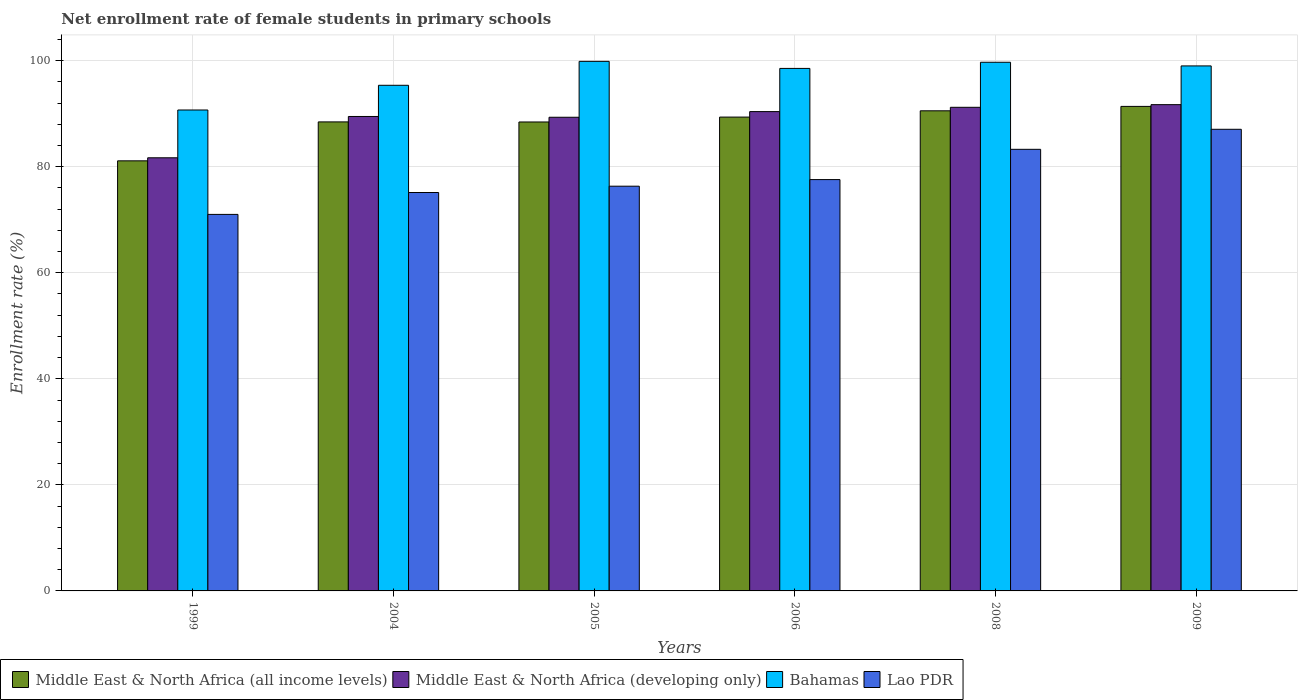Are the number of bars per tick equal to the number of legend labels?
Your answer should be compact. Yes. Are the number of bars on each tick of the X-axis equal?
Give a very brief answer. Yes. How many bars are there on the 1st tick from the left?
Provide a short and direct response. 4. What is the label of the 1st group of bars from the left?
Your response must be concise. 1999. In how many cases, is the number of bars for a given year not equal to the number of legend labels?
Keep it short and to the point. 0. What is the net enrollment rate of female students in primary schools in Bahamas in 2005?
Ensure brevity in your answer.  99.86. Across all years, what is the maximum net enrollment rate of female students in primary schools in Lao PDR?
Offer a very short reply. 87.05. Across all years, what is the minimum net enrollment rate of female students in primary schools in Bahamas?
Give a very brief answer. 90.69. In which year was the net enrollment rate of female students in primary schools in Middle East & North Africa (developing only) maximum?
Your answer should be compact. 2009. What is the total net enrollment rate of female students in primary schools in Middle East & North Africa (developing only) in the graph?
Offer a very short reply. 533.75. What is the difference between the net enrollment rate of female students in primary schools in Middle East & North Africa (all income levels) in 1999 and that in 2004?
Your answer should be very brief. -7.34. What is the difference between the net enrollment rate of female students in primary schools in Middle East & North Africa (all income levels) in 2006 and the net enrollment rate of female students in primary schools in Lao PDR in 2004?
Keep it short and to the point. 14.22. What is the average net enrollment rate of female students in primary schools in Bahamas per year?
Provide a short and direct response. 97.19. In the year 2008, what is the difference between the net enrollment rate of female students in primary schools in Lao PDR and net enrollment rate of female students in primary schools in Middle East & North Africa (all income levels)?
Your answer should be very brief. -7.26. In how many years, is the net enrollment rate of female students in primary schools in Middle East & North Africa (all income levels) greater than 84 %?
Ensure brevity in your answer.  5. What is the ratio of the net enrollment rate of female students in primary schools in Middle East & North Africa (all income levels) in 1999 to that in 2005?
Offer a terse response. 0.92. What is the difference between the highest and the second highest net enrollment rate of female students in primary schools in Middle East & North Africa (all income levels)?
Your answer should be very brief. 0.83. What is the difference between the highest and the lowest net enrollment rate of female students in primary schools in Middle East & North Africa (developing only)?
Give a very brief answer. 10.02. In how many years, is the net enrollment rate of female students in primary schools in Bahamas greater than the average net enrollment rate of female students in primary schools in Bahamas taken over all years?
Ensure brevity in your answer.  4. Is the sum of the net enrollment rate of female students in primary schools in Middle East & North Africa (developing only) in 2004 and 2008 greater than the maximum net enrollment rate of female students in primary schools in Lao PDR across all years?
Make the answer very short. Yes. What does the 2nd bar from the left in 2008 represents?
Offer a very short reply. Middle East & North Africa (developing only). What does the 4th bar from the right in 2004 represents?
Offer a terse response. Middle East & North Africa (all income levels). Is it the case that in every year, the sum of the net enrollment rate of female students in primary schools in Lao PDR and net enrollment rate of female students in primary schools in Middle East & North Africa (developing only) is greater than the net enrollment rate of female students in primary schools in Bahamas?
Make the answer very short. Yes. How many bars are there?
Make the answer very short. 24. Are all the bars in the graph horizontal?
Your answer should be compact. No. Are the values on the major ticks of Y-axis written in scientific E-notation?
Your answer should be compact. No. Does the graph contain any zero values?
Ensure brevity in your answer.  No. How many legend labels are there?
Keep it short and to the point. 4. How are the legend labels stacked?
Your response must be concise. Horizontal. What is the title of the graph?
Offer a terse response. Net enrollment rate of female students in primary schools. What is the label or title of the Y-axis?
Give a very brief answer. Enrollment rate (%). What is the Enrollment rate (%) of Middle East & North Africa (all income levels) in 1999?
Your answer should be very brief. 81.1. What is the Enrollment rate (%) in Middle East & North Africa (developing only) in 1999?
Make the answer very short. 81.68. What is the Enrollment rate (%) of Bahamas in 1999?
Make the answer very short. 90.69. What is the Enrollment rate (%) of Lao PDR in 1999?
Offer a very short reply. 71. What is the Enrollment rate (%) in Middle East & North Africa (all income levels) in 2004?
Provide a short and direct response. 88.44. What is the Enrollment rate (%) in Middle East & North Africa (developing only) in 2004?
Your answer should be compact. 89.47. What is the Enrollment rate (%) in Bahamas in 2004?
Offer a terse response. 95.35. What is the Enrollment rate (%) of Lao PDR in 2004?
Your answer should be very brief. 75.13. What is the Enrollment rate (%) in Middle East & North Africa (all income levels) in 2005?
Offer a terse response. 88.43. What is the Enrollment rate (%) in Middle East & North Africa (developing only) in 2005?
Make the answer very short. 89.32. What is the Enrollment rate (%) in Bahamas in 2005?
Ensure brevity in your answer.  99.86. What is the Enrollment rate (%) in Lao PDR in 2005?
Offer a terse response. 76.32. What is the Enrollment rate (%) in Middle East & North Africa (all income levels) in 2006?
Your response must be concise. 89.35. What is the Enrollment rate (%) of Middle East & North Africa (developing only) in 2006?
Offer a very short reply. 90.39. What is the Enrollment rate (%) of Bahamas in 2006?
Offer a terse response. 98.53. What is the Enrollment rate (%) in Lao PDR in 2006?
Provide a short and direct response. 77.57. What is the Enrollment rate (%) of Middle East & North Africa (all income levels) in 2008?
Keep it short and to the point. 90.54. What is the Enrollment rate (%) of Middle East & North Africa (developing only) in 2008?
Your response must be concise. 91.2. What is the Enrollment rate (%) of Bahamas in 2008?
Provide a short and direct response. 99.69. What is the Enrollment rate (%) of Lao PDR in 2008?
Your answer should be compact. 83.27. What is the Enrollment rate (%) of Middle East & North Africa (all income levels) in 2009?
Offer a very short reply. 91.37. What is the Enrollment rate (%) of Middle East & North Africa (developing only) in 2009?
Give a very brief answer. 91.7. What is the Enrollment rate (%) of Bahamas in 2009?
Keep it short and to the point. 99. What is the Enrollment rate (%) in Lao PDR in 2009?
Offer a terse response. 87.05. Across all years, what is the maximum Enrollment rate (%) in Middle East & North Africa (all income levels)?
Your response must be concise. 91.37. Across all years, what is the maximum Enrollment rate (%) of Middle East & North Africa (developing only)?
Make the answer very short. 91.7. Across all years, what is the maximum Enrollment rate (%) in Bahamas?
Ensure brevity in your answer.  99.86. Across all years, what is the maximum Enrollment rate (%) of Lao PDR?
Keep it short and to the point. 87.05. Across all years, what is the minimum Enrollment rate (%) in Middle East & North Africa (all income levels)?
Keep it short and to the point. 81.1. Across all years, what is the minimum Enrollment rate (%) in Middle East & North Africa (developing only)?
Make the answer very short. 81.68. Across all years, what is the minimum Enrollment rate (%) of Bahamas?
Keep it short and to the point. 90.69. Across all years, what is the minimum Enrollment rate (%) in Lao PDR?
Provide a short and direct response. 71. What is the total Enrollment rate (%) in Middle East & North Africa (all income levels) in the graph?
Provide a short and direct response. 529.24. What is the total Enrollment rate (%) of Middle East & North Africa (developing only) in the graph?
Your answer should be very brief. 533.75. What is the total Enrollment rate (%) in Bahamas in the graph?
Ensure brevity in your answer.  583.13. What is the total Enrollment rate (%) of Lao PDR in the graph?
Give a very brief answer. 470.35. What is the difference between the Enrollment rate (%) of Middle East & North Africa (all income levels) in 1999 and that in 2004?
Offer a terse response. -7.34. What is the difference between the Enrollment rate (%) in Middle East & North Africa (developing only) in 1999 and that in 2004?
Provide a short and direct response. -7.79. What is the difference between the Enrollment rate (%) in Bahamas in 1999 and that in 2004?
Provide a succinct answer. -4.66. What is the difference between the Enrollment rate (%) of Lao PDR in 1999 and that in 2004?
Offer a very short reply. -4.13. What is the difference between the Enrollment rate (%) of Middle East & North Africa (all income levels) in 1999 and that in 2005?
Your answer should be very brief. -7.33. What is the difference between the Enrollment rate (%) in Middle East & North Africa (developing only) in 1999 and that in 2005?
Offer a very short reply. -7.64. What is the difference between the Enrollment rate (%) of Bahamas in 1999 and that in 2005?
Make the answer very short. -9.17. What is the difference between the Enrollment rate (%) in Lao PDR in 1999 and that in 2005?
Offer a very short reply. -5.32. What is the difference between the Enrollment rate (%) in Middle East & North Africa (all income levels) in 1999 and that in 2006?
Ensure brevity in your answer.  -8.25. What is the difference between the Enrollment rate (%) of Middle East & North Africa (developing only) in 1999 and that in 2006?
Make the answer very short. -8.71. What is the difference between the Enrollment rate (%) of Bahamas in 1999 and that in 2006?
Your response must be concise. -7.84. What is the difference between the Enrollment rate (%) in Lao PDR in 1999 and that in 2006?
Ensure brevity in your answer.  -6.57. What is the difference between the Enrollment rate (%) of Middle East & North Africa (all income levels) in 1999 and that in 2008?
Keep it short and to the point. -9.43. What is the difference between the Enrollment rate (%) of Middle East & North Africa (developing only) in 1999 and that in 2008?
Provide a short and direct response. -9.52. What is the difference between the Enrollment rate (%) in Bahamas in 1999 and that in 2008?
Provide a short and direct response. -9. What is the difference between the Enrollment rate (%) of Lao PDR in 1999 and that in 2008?
Provide a short and direct response. -12.27. What is the difference between the Enrollment rate (%) in Middle East & North Africa (all income levels) in 1999 and that in 2009?
Give a very brief answer. -10.26. What is the difference between the Enrollment rate (%) of Middle East & North Africa (developing only) in 1999 and that in 2009?
Keep it short and to the point. -10.02. What is the difference between the Enrollment rate (%) of Bahamas in 1999 and that in 2009?
Offer a very short reply. -8.31. What is the difference between the Enrollment rate (%) in Lao PDR in 1999 and that in 2009?
Offer a terse response. -16.05. What is the difference between the Enrollment rate (%) of Middle East & North Africa (all income levels) in 2004 and that in 2005?
Provide a succinct answer. 0.01. What is the difference between the Enrollment rate (%) in Middle East & North Africa (developing only) in 2004 and that in 2005?
Your response must be concise. 0.15. What is the difference between the Enrollment rate (%) of Bahamas in 2004 and that in 2005?
Make the answer very short. -4.51. What is the difference between the Enrollment rate (%) of Lao PDR in 2004 and that in 2005?
Offer a very short reply. -1.19. What is the difference between the Enrollment rate (%) in Middle East & North Africa (all income levels) in 2004 and that in 2006?
Offer a very short reply. -0.91. What is the difference between the Enrollment rate (%) in Middle East & North Africa (developing only) in 2004 and that in 2006?
Offer a terse response. -0.92. What is the difference between the Enrollment rate (%) of Bahamas in 2004 and that in 2006?
Your response must be concise. -3.18. What is the difference between the Enrollment rate (%) of Lao PDR in 2004 and that in 2006?
Offer a very short reply. -2.44. What is the difference between the Enrollment rate (%) of Middle East & North Africa (all income levels) in 2004 and that in 2008?
Offer a very short reply. -2.09. What is the difference between the Enrollment rate (%) of Middle East & North Africa (developing only) in 2004 and that in 2008?
Make the answer very short. -1.73. What is the difference between the Enrollment rate (%) of Bahamas in 2004 and that in 2008?
Your answer should be very brief. -4.34. What is the difference between the Enrollment rate (%) in Lao PDR in 2004 and that in 2008?
Provide a succinct answer. -8.15. What is the difference between the Enrollment rate (%) of Middle East & North Africa (all income levels) in 2004 and that in 2009?
Offer a terse response. -2.92. What is the difference between the Enrollment rate (%) in Middle East & North Africa (developing only) in 2004 and that in 2009?
Your answer should be very brief. -2.23. What is the difference between the Enrollment rate (%) of Bahamas in 2004 and that in 2009?
Your response must be concise. -3.65. What is the difference between the Enrollment rate (%) in Lao PDR in 2004 and that in 2009?
Offer a terse response. -11.92. What is the difference between the Enrollment rate (%) of Middle East & North Africa (all income levels) in 2005 and that in 2006?
Give a very brief answer. -0.92. What is the difference between the Enrollment rate (%) in Middle East & North Africa (developing only) in 2005 and that in 2006?
Give a very brief answer. -1.07. What is the difference between the Enrollment rate (%) of Bahamas in 2005 and that in 2006?
Keep it short and to the point. 1.33. What is the difference between the Enrollment rate (%) of Lao PDR in 2005 and that in 2006?
Your answer should be very brief. -1.25. What is the difference between the Enrollment rate (%) of Middle East & North Africa (all income levels) in 2005 and that in 2008?
Your response must be concise. -2.11. What is the difference between the Enrollment rate (%) of Middle East & North Africa (developing only) in 2005 and that in 2008?
Offer a terse response. -1.88. What is the difference between the Enrollment rate (%) of Bahamas in 2005 and that in 2008?
Your answer should be very brief. 0.17. What is the difference between the Enrollment rate (%) of Lao PDR in 2005 and that in 2008?
Keep it short and to the point. -6.95. What is the difference between the Enrollment rate (%) of Middle East & North Africa (all income levels) in 2005 and that in 2009?
Ensure brevity in your answer.  -2.94. What is the difference between the Enrollment rate (%) in Middle East & North Africa (developing only) in 2005 and that in 2009?
Offer a very short reply. -2.38. What is the difference between the Enrollment rate (%) in Bahamas in 2005 and that in 2009?
Your answer should be compact. 0.86. What is the difference between the Enrollment rate (%) of Lao PDR in 2005 and that in 2009?
Your response must be concise. -10.73. What is the difference between the Enrollment rate (%) of Middle East & North Africa (all income levels) in 2006 and that in 2008?
Your answer should be compact. -1.18. What is the difference between the Enrollment rate (%) of Middle East & North Africa (developing only) in 2006 and that in 2008?
Provide a short and direct response. -0.81. What is the difference between the Enrollment rate (%) of Bahamas in 2006 and that in 2008?
Offer a very short reply. -1.16. What is the difference between the Enrollment rate (%) of Lao PDR in 2006 and that in 2008?
Offer a terse response. -5.71. What is the difference between the Enrollment rate (%) of Middle East & North Africa (all income levels) in 2006 and that in 2009?
Give a very brief answer. -2.01. What is the difference between the Enrollment rate (%) of Middle East & North Africa (developing only) in 2006 and that in 2009?
Make the answer very short. -1.31. What is the difference between the Enrollment rate (%) of Bahamas in 2006 and that in 2009?
Offer a very short reply. -0.47. What is the difference between the Enrollment rate (%) of Lao PDR in 2006 and that in 2009?
Your answer should be very brief. -9.48. What is the difference between the Enrollment rate (%) of Middle East & North Africa (all income levels) in 2008 and that in 2009?
Ensure brevity in your answer.  -0.83. What is the difference between the Enrollment rate (%) in Middle East & North Africa (developing only) in 2008 and that in 2009?
Provide a succinct answer. -0.5. What is the difference between the Enrollment rate (%) of Bahamas in 2008 and that in 2009?
Offer a very short reply. 0.69. What is the difference between the Enrollment rate (%) of Lao PDR in 2008 and that in 2009?
Offer a very short reply. -3.78. What is the difference between the Enrollment rate (%) in Middle East & North Africa (all income levels) in 1999 and the Enrollment rate (%) in Middle East & North Africa (developing only) in 2004?
Ensure brevity in your answer.  -8.37. What is the difference between the Enrollment rate (%) in Middle East & North Africa (all income levels) in 1999 and the Enrollment rate (%) in Bahamas in 2004?
Your response must be concise. -14.25. What is the difference between the Enrollment rate (%) of Middle East & North Africa (all income levels) in 1999 and the Enrollment rate (%) of Lao PDR in 2004?
Your response must be concise. 5.97. What is the difference between the Enrollment rate (%) of Middle East & North Africa (developing only) in 1999 and the Enrollment rate (%) of Bahamas in 2004?
Make the answer very short. -13.67. What is the difference between the Enrollment rate (%) in Middle East & North Africa (developing only) in 1999 and the Enrollment rate (%) in Lao PDR in 2004?
Keep it short and to the point. 6.55. What is the difference between the Enrollment rate (%) of Bahamas in 1999 and the Enrollment rate (%) of Lao PDR in 2004?
Ensure brevity in your answer.  15.56. What is the difference between the Enrollment rate (%) of Middle East & North Africa (all income levels) in 1999 and the Enrollment rate (%) of Middle East & North Africa (developing only) in 2005?
Ensure brevity in your answer.  -8.22. What is the difference between the Enrollment rate (%) in Middle East & North Africa (all income levels) in 1999 and the Enrollment rate (%) in Bahamas in 2005?
Your answer should be compact. -18.76. What is the difference between the Enrollment rate (%) in Middle East & North Africa (all income levels) in 1999 and the Enrollment rate (%) in Lao PDR in 2005?
Your answer should be compact. 4.78. What is the difference between the Enrollment rate (%) of Middle East & North Africa (developing only) in 1999 and the Enrollment rate (%) of Bahamas in 2005?
Provide a succinct answer. -18.18. What is the difference between the Enrollment rate (%) of Middle East & North Africa (developing only) in 1999 and the Enrollment rate (%) of Lao PDR in 2005?
Offer a terse response. 5.36. What is the difference between the Enrollment rate (%) in Bahamas in 1999 and the Enrollment rate (%) in Lao PDR in 2005?
Provide a short and direct response. 14.37. What is the difference between the Enrollment rate (%) of Middle East & North Africa (all income levels) in 1999 and the Enrollment rate (%) of Middle East & North Africa (developing only) in 2006?
Your answer should be compact. -9.28. What is the difference between the Enrollment rate (%) in Middle East & North Africa (all income levels) in 1999 and the Enrollment rate (%) in Bahamas in 2006?
Your response must be concise. -17.43. What is the difference between the Enrollment rate (%) in Middle East & North Africa (all income levels) in 1999 and the Enrollment rate (%) in Lao PDR in 2006?
Provide a succinct answer. 3.53. What is the difference between the Enrollment rate (%) of Middle East & North Africa (developing only) in 1999 and the Enrollment rate (%) of Bahamas in 2006?
Your answer should be compact. -16.85. What is the difference between the Enrollment rate (%) in Middle East & North Africa (developing only) in 1999 and the Enrollment rate (%) in Lao PDR in 2006?
Your answer should be very brief. 4.11. What is the difference between the Enrollment rate (%) of Bahamas in 1999 and the Enrollment rate (%) of Lao PDR in 2006?
Offer a very short reply. 13.12. What is the difference between the Enrollment rate (%) in Middle East & North Africa (all income levels) in 1999 and the Enrollment rate (%) in Middle East & North Africa (developing only) in 2008?
Ensure brevity in your answer.  -10.09. What is the difference between the Enrollment rate (%) of Middle East & North Africa (all income levels) in 1999 and the Enrollment rate (%) of Bahamas in 2008?
Provide a short and direct response. -18.59. What is the difference between the Enrollment rate (%) of Middle East & North Africa (all income levels) in 1999 and the Enrollment rate (%) of Lao PDR in 2008?
Keep it short and to the point. -2.17. What is the difference between the Enrollment rate (%) in Middle East & North Africa (developing only) in 1999 and the Enrollment rate (%) in Bahamas in 2008?
Your answer should be very brief. -18.02. What is the difference between the Enrollment rate (%) in Middle East & North Africa (developing only) in 1999 and the Enrollment rate (%) in Lao PDR in 2008?
Give a very brief answer. -1.6. What is the difference between the Enrollment rate (%) in Bahamas in 1999 and the Enrollment rate (%) in Lao PDR in 2008?
Offer a terse response. 7.42. What is the difference between the Enrollment rate (%) of Middle East & North Africa (all income levels) in 1999 and the Enrollment rate (%) of Middle East & North Africa (developing only) in 2009?
Your response must be concise. -10.59. What is the difference between the Enrollment rate (%) in Middle East & North Africa (all income levels) in 1999 and the Enrollment rate (%) in Bahamas in 2009?
Your answer should be compact. -17.9. What is the difference between the Enrollment rate (%) in Middle East & North Africa (all income levels) in 1999 and the Enrollment rate (%) in Lao PDR in 2009?
Your answer should be compact. -5.95. What is the difference between the Enrollment rate (%) in Middle East & North Africa (developing only) in 1999 and the Enrollment rate (%) in Bahamas in 2009?
Keep it short and to the point. -17.33. What is the difference between the Enrollment rate (%) in Middle East & North Africa (developing only) in 1999 and the Enrollment rate (%) in Lao PDR in 2009?
Keep it short and to the point. -5.37. What is the difference between the Enrollment rate (%) of Bahamas in 1999 and the Enrollment rate (%) of Lao PDR in 2009?
Provide a succinct answer. 3.64. What is the difference between the Enrollment rate (%) in Middle East & North Africa (all income levels) in 2004 and the Enrollment rate (%) in Middle East & North Africa (developing only) in 2005?
Your response must be concise. -0.88. What is the difference between the Enrollment rate (%) of Middle East & North Africa (all income levels) in 2004 and the Enrollment rate (%) of Bahamas in 2005?
Make the answer very short. -11.42. What is the difference between the Enrollment rate (%) in Middle East & North Africa (all income levels) in 2004 and the Enrollment rate (%) in Lao PDR in 2005?
Provide a short and direct response. 12.12. What is the difference between the Enrollment rate (%) of Middle East & North Africa (developing only) in 2004 and the Enrollment rate (%) of Bahamas in 2005?
Offer a very short reply. -10.39. What is the difference between the Enrollment rate (%) of Middle East & North Africa (developing only) in 2004 and the Enrollment rate (%) of Lao PDR in 2005?
Your answer should be compact. 13.15. What is the difference between the Enrollment rate (%) in Bahamas in 2004 and the Enrollment rate (%) in Lao PDR in 2005?
Offer a very short reply. 19.03. What is the difference between the Enrollment rate (%) of Middle East & North Africa (all income levels) in 2004 and the Enrollment rate (%) of Middle East & North Africa (developing only) in 2006?
Offer a very short reply. -1.94. What is the difference between the Enrollment rate (%) of Middle East & North Africa (all income levels) in 2004 and the Enrollment rate (%) of Bahamas in 2006?
Give a very brief answer. -10.09. What is the difference between the Enrollment rate (%) in Middle East & North Africa (all income levels) in 2004 and the Enrollment rate (%) in Lao PDR in 2006?
Your answer should be very brief. 10.88. What is the difference between the Enrollment rate (%) in Middle East & North Africa (developing only) in 2004 and the Enrollment rate (%) in Bahamas in 2006?
Your answer should be compact. -9.06. What is the difference between the Enrollment rate (%) in Middle East & North Africa (developing only) in 2004 and the Enrollment rate (%) in Lao PDR in 2006?
Your answer should be very brief. 11.9. What is the difference between the Enrollment rate (%) in Bahamas in 2004 and the Enrollment rate (%) in Lao PDR in 2006?
Your answer should be very brief. 17.78. What is the difference between the Enrollment rate (%) in Middle East & North Africa (all income levels) in 2004 and the Enrollment rate (%) in Middle East & North Africa (developing only) in 2008?
Offer a very short reply. -2.75. What is the difference between the Enrollment rate (%) in Middle East & North Africa (all income levels) in 2004 and the Enrollment rate (%) in Bahamas in 2008?
Provide a succinct answer. -11.25. What is the difference between the Enrollment rate (%) in Middle East & North Africa (all income levels) in 2004 and the Enrollment rate (%) in Lao PDR in 2008?
Keep it short and to the point. 5.17. What is the difference between the Enrollment rate (%) of Middle East & North Africa (developing only) in 2004 and the Enrollment rate (%) of Bahamas in 2008?
Keep it short and to the point. -10.22. What is the difference between the Enrollment rate (%) of Middle East & North Africa (developing only) in 2004 and the Enrollment rate (%) of Lao PDR in 2008?
Give a very brief answer. 6.19. What is the difference between the Enrollment rate (%) in Bahamas in 2004 and the Enrollment rate (%) in Lao PDR in 2008?
Your answer should be compact. 12.08. What is the difference between the Enrollment rate (%) of Middle East & North Africa (all income levels) in 2004 and the Enrollment rate (%) of Middle East & North Africa (developing only) in 2009?
Give a very brief answer. -3.25. What is the difference between the Enrollment rate (%) of Middle East & North Africa (all income levels) in 2004 and the Enrollment rate (%) of Bahamas in 2009?
Offer a terse response. -10.56. What is the difference between the Enrollment rate (%) of Middle East & North Africa (all income levels) in 2004 and the Enrollment rate (%) of Lao PDR in 2009?
Give a very brief answer. 1.39. What is the difference between the Enrollment rate (%) of Middle East & North Africa (developing only) in 2004 and the Enrollment rate (%) of Bahamas in 2009?
Make the answer very short. -9.53. What is the difference between the Enrollment rate (%) in Middle East & North Africa (developing only) in 2004 and the Enrollment rate (%) in Lao PDR in 2009?
Provide a short and direct response. 2.42. What is the difference between the Enrollment rate (%) in Bahamas in 2004 and the Enrollment rate (%) in Lao PDR in 2009?
Offer a terse response. 8.3. What is the difference between the Enrollment rate (%) in Middle East & North Africa (all income levels) in 2005 and the Enrollment rate (%) in Middle East & North Africa (developing only) in 2006?
Your response must be concise. -1.96. What is the difference between the Enrollment rate (%) of Middle East & North Africa (all income levels) in 2005 and the Enrollment rate (%) of Bahamas in 2006?
Your answer should be very brief. -10.1. What is the difference between the Enrollment rate (%) in Middle East & North Africa (all income levels) in 2005 and the Enrollment rate (%) in Lao PDR in 2006?
Provide a succinct answer. 10.86. What is the difference between the Enrollment rate (%) of Middle East & North Africa (developing only) in 2005 and the Enrollment rate (%) of Bahamas in 2006?
Give a very brief answer. -9.21. What is the difference between the Enrollment rate (%) in Middle East & North Africa (developing only) in 2005 and the Enrollment rate (%) in Lao PDR in 2006?
Your answer should be compact. 11.75. What is the difference between the Enrollment rate (%) of Bahamas in 2005 and the Enrollment rate (%) of Lao PDR in 2006?
Provide a succinct answer. 22.29. What is the difference between the Enrollment rate (%) in Middle East & North Africa (all income levels) in 2005 and the Enrollment rate (%) in Middle East & North Africa (developing only) in 2008?
Keep it short and to the point. -2.77. What is the difference between the Enrollment rate (%) of Middle East & North Africa (all income levels) in 2005 and the Enrollment rate (%) of Bahamas in 2008?
Your answer should be very brief. -11.26. What is the difference between the Enrollment rate (%) of Middle East & North Africa (all income levels) in 2005 and the Enrollment rate (%) of Lao PDR in 2008?
Keep it short and to the point. 5.16. What is the difference between the Enrollment rate (%) of Middle East & North Africa (developing only) in 2005 and the Enrollment rate (%) of Bahamas in 2008?
Your answer should be very brief. -10.37. What is the difference between the Enrollment rate (%) in Middle East & North Africa (developing only) in 2005 and the Enrollment rate (%) in Lao PDR in 2008?
Keep it short and to the point. 6.05. What is the difference between the Enrollment rate (%) of Bahamas in 2005 and the Enrollment rate (%) of Lao PDR in 2008?
Provide a succinct answer. 16.59. What is the difference between the Enrollment rate (%) of Middle East & North Africa (all income levels) in 2005 and the Enrollment rate (%) of Middle East & North Africa (developing only) in 2009?
Give a very brief answer. -3.27. What is the difference between the Enrollment rate (%) of Middle East & North Africa (all income levels) in 2005 and the Enrollment rate (%) of Bahamas in 2009?
Provide a succinct answer. -10.57. What is the difference between the Enrollment rate (%) of Middle East & North Africa (all income levels) in 2005 and the Enrollment rate (%) of Lao PDR in 2009?
Give a very brief answer. 1.38. What is the difference between the Enrollment rate (%) of Middle East & North Africa (developing only) in 2005 and the Enrollment rate (%) of Bahamas in 2009?
Make the answer very short. -9.68. What is the difference between the Enrollment rate (%) in Middle East & North Africa (developing only) in 2005 and the Enrollment rate (%) in Lao PDR in 2009?
Provide a short and direct response. 2.27. What is the difference between the Enrollment rate (%) in Bahamas in 2005 and the Enrollment rate (%) in Lao PDR in 2009?
Offer a terse response. 12.81. What is the difference between the Enrollment rate (%) of Middle East & North Africa (all income levels) in 2006 and the Enrollment rate (%) of Middle East & North Africa (developing only) in 2008?
Ensure brevity in your answer.  -1.84. What is the difference between the Enrollment rate (%) in Middle East & North Africa (all income levels) in 2006 and the Enrollment rate (%) in Bahamas in 2008?
Your answer should be very brief. -10.34. What is the difference between the Enrollment rate (%) of Middle East & North Africa (all income levels) in 2006 and the Enrollment rate (%) of Lao PDR in 2008?
Provide a short and direct response. 6.08. What is the difference between the Enrollment rate (%) in Middle East & North Africa (developing only) in 2006 and the Enrollment rate (%) in Bahamas in 2008?
Offer a very short reply. -9.31. What is the difference between the Enrollment rate (%) of Middle East & North Africa (developing only) in 2006 and the Enrollment rate (%) of Lao PDR in 2008?
Provide a succinct answer. 7.11. What is the difference between the Enrollment rate (%) of Bahamas in 2006 and the Enrollment rate (%) of Lao PDR in 2008?
Your answer should be very brief. 15.26. What is the difference between the Enrollment rate (%) of Middle East & North Africa (all income levels) in 2006 and the Enrollment rate (%) of Middle East & North Africa (developing only) in 2009?
Ensure brevity in your answer.  -2.34. What is the difference between the Enrollment rate (%) in Middle East & North Africa (all income levels) in 2006 and the Enrollment rate (%) in Bahamas in 2009?
Ensure brevity in your answer.  -9.65. What is the difference between the Enrollment rate (%) in Middle East & North Africa (all income levels) in 2006 and the Enrollment rate (%) in Lao PDR in 2009?
Provide a short and direct response. 2.3. What is the difference between the Enrollment rate (%) in Middle East & North Africa (developing only) in 2006 and the Enrollment rate (%) in Bahamas in 2009?
Provide a short and direct response. -8.62. What is the difference between the Enrollment rate (%) in Middle East & North Africa (developing only) in 2006 and the Enrollment rate (%) in Lao PDR in 2009?
Make the answer very short. 3.33. What is the difference between the Enrollment rate (%) in Bahamas in 2006 and the Enrollment rate (%) in Lao PDR in 2009?
Provide a succinct answer. 11.48. What is the difference between the Enrollment rate (%) in Middle East & North Africa (all income levels) in 2008 and the Enrollment rate (%) in Middle East & North Africa (developing only) in 2009?
Provide a short and direct response. -1.16. What is the difference between the Enrollment rate (%) in Middle East & North Africa (all income levels) in 2008 and the Enrollment rate (%) in Bahamas in 2009?
Keep it short and to the point. -8.47. What is the difference between the Enrollment rate (%) of Middle East & North Africa (all income levels) in 2008 and the Enrollment rate (%) of Lao PDR in 2009?
Provide a succinct answer. 3.48. What is the difference between the Enrollment rate (%) of Middle East & North Africa (developing only) in 2008 and the Enrollment rate (%) of Bahamas in 2009?
Your response must be concise. -7.81. What is the difference between the Enrollment rate (%) in Middle East & North Africa (developing only) in 2008 and the Enrollment rate (%) in Lao PDR in 2009?
Ensure brevity in your answer.  4.15. What is the difference between the Enrollment rate (%) in Bahamas in 2008 and the Enrollment rate (%) in Lao PDR in 2009?
Keep it short and to the point. 12.64. What is the average Enrollment rate (%) in Middle East & North Africa (all income levels) per year?
Offer a very short reply. 88.21. What is the average Enrollment rate (%) of Middle East & North Africa (developing only) per year?
Provide a succinct answer. 88.96. What is the average Enrollment rate (%) in Bahamas per year?
Offer a terse response. 97.19. What is the average Enrollment rate (%) of Lao PDR per year?
Provide a short and direct response. 78.39. In the year 1999, what is the difference between the Enrollment rate (%) of Middle East & North Africa (all income levels) and Enrollment rate (%) of Middle East & North Africa (developing only)?
Offer a terse response. -0.57. In the year 1999, what is the difference between the Enrollment rate (%) in Middle East & North Africa (all income levels) and Enrollment rate (%) in Bahamas?
Provide a succinct answer. -9.59. In the year 1999, what is the difference between the Enrollment rate (%) of Middle East & North Africa (all income levels) and Enrollment rate (%) of Lao PDR?
Give a very brief answer. 10.1. In the year 1999, what is the difference between the Enrollment rate (%) of Middle East & North Africa (developing only) and Enrollment rate (%) of Bahamas?
Ensure brevity in your answer.  -9.01. In the year 1999, what is the difference between the Enrollment rate (%) in Middle East & North Africa (developing only) and Enrollment rate (%) in Lao PDR?
Your answer should be compact. 10.68. In the year 1999, what is the difference between the Enrollment rate (%) in Bahamas and Enrollment rate (%) in Lao PDR?
Provide a succinct answer. 19.69. In the year 2004, what is the difference between the Enrollment rate (%) in Middle East & North Africa (all income levels) and Enrollment rate (%) in Middle East & North Africa (developing only)?
Your answer should be compact. -1.02. In the year 2004, what is the difference between the Enrollment rate (%) of Middle East & North Africa (all income levels) and Enrollment rate (%) of Bahamas?
Give a very brief answer. -6.91. In the year 2004, what is the difference between the Enrollment rate (%) of Middle East & North Africa (all income levels) and Enrollment rate (%) of Lao PDR?
Offer a terse response. 13.32. In the year 2004, what is the difference between the Enrollment rate (%) in Middle East & North Africa (developing only) and Enrollment rate (%) in Bahamas?
Provide a short and direct response. -5.88. In the year 2004, what is the difference between the Enrollment rate (%) in Middle East & North Africa (developing only) and Enrollment rate (%) in Lao PDR?
Keep it short and to the point. 14.34. In the year 2004, what is the difference between the Enrollment rate (%) of Bahamas and Enrollment rate (%) of Lao PDR?
Offer a terse response. 20.22. In the year 2005, what is the difference between the Enrollment rate (%) of Middle East & North Africa (all income levels) and Enrollment rate (%) of Middle East & North Africa (developing only)?
Your answer should be very brief. -0.89. In the year 2005, what is the difference between the Enrollment rate (%) of Middle East & North Africa (all income levels) and Enrollment rate (%) of Bahamas?
Make the answer very short. -11.43. In the year 2005, what is the difference between the Enrollment rate (%) in Middle East & North Africa (all income levels) and Enrollment rate (%) in Lao PDR?
Your answer should be very brief. 12.11. In the year 2005, what is the difference between the Enrollment rate (%) of Middle East & North Africa (developing only) and Enrollment rate (%) of Bahamas?
Provide a succinct answer. -10.54. In the year 2005, what is the difference between the Enrollment rate (%) of Middle East & North Africa (developing only) and Enrollment rate (%) of Lao PDR?
Your answer should be compact. 13. In the year 2005, what is the difference between the Enrollment rate (%) in Bahamas and Enrollment rate (%) in Lao PDR?
Give a very brief answer. 23.54. In the year 2006, what is the difference between the Enrollment rate (%) in Middle East & North Africa (all income levels) and Enrollment rate (%) in Middle East & North Africa (developing only)?
Your response must be concise. -1.03. In the year 2006, what is the difference between the Enrollment rate (%) of Middle East & North Africa (all income levels) and Enrollment rate (%) of Bahamas?
Provide a short and direct response. -9.18. In the year 2006, what is the difference between the Enrollment rate (%) of Middle East & North Africa (all income levels) and Enrollment rate (%) of Lao PDR?
Your response must be concise. 11.78. In the year 2006, what is the difference between the Enrollment rate (%) in Middle East & North Africa (developing only) and Enrollment rate (%) in Bahamas?
Ensure brevity in your answer.  -8.15. In the year 2006, what is the difference between the Enrollment rate (%) of Middle East & North Africa (developing only) and Enrollment rate (%) of Lao PDR?
Your response must be concise. 12.82. In the year 2006, what is the difference between the Enrollment rate (%) in Bahamas and Enrollment rate (%) in Lao PDR?
Your response must be concise. 20.96. In the year 2008, what is the difference between the Enrollment rate (%) of Middle East & North Africa (all income levels) and Enrollment rate (%) of Middle East & North Africa (developing only)?
Your response must be concise. -0.66. In the year 2008, what is the difference between the Enrollment rate (%) in Middle East & North Africa (all income levels) and Enrollment rate (%) in Bahamas?
Keep it short and to the point. -9.16. In the year 2008, what is the difference between the Enrollment rate (%) of Middle East & North Africa (all income levels) and Enrollment rate (%) of Lao PDR?
Ensure brevity in your answer.  7.26. In the year 2008, what is the difference between the Enrollment rate (%) of Middle East & North Africa (developing only) and Enrollment rate (%) of Bahamas?
Keep it short and to the point. -8.5. In the year 2008, what is the difference between the Enrollment rate (%) in Middle East & North Africa (developing only) and Enrollment rate (%) in Lao PDR?
Your answer should be compact. 7.92. In the year 2008, what is the difference between the Enrollment rate (%) in Bahamas and Enrollment rate (%) in Lao PDR?
Your answer should be very brief. 16.42. In the year 2009, what is the difference between the Enrollment rate (%) of Middle East & North Africa (all income levels) and Enrollment rate (%) of Middle East & North Africa (developing only)?
Keep it short and to the point. -0.33. In the year 2009, what is the difference between the Enrollment rate (%) of Middle East & North Africa (all income levels) and Enrollment rate (%) of Bahamas?
Keep it short and to the point. -7.64. In the year 2009, what is the difference between the Enrollment rate (%) in Middle East & North Africa (all income levels) and Enrollment rate (%) in Lao PDR?
Ensure brevity in your answer.  4.31. In the year 2009, what is the difference between the Enrollment rate (%) in Middle East & North Africa (developing only) and Enrollment rate (%) in Bahamas?
Your answer should be very brief. -7.31. In the year 2009, what is the difference between the Enrollment rate (%) of Middle East & North Africa (developing only) and Enrollment rate (%) of Lao PDR?
Keep it short and to the point. 4.64. In the year 2009, what is the difference between the Enrollment rate (%) in Bahamas and Enrollment rate (%) in Lao PDR?
Provide a short and direct response. 11.95. What is the ratio of the Enrollment rate (%) of Middle East & North Africa (all income levels) in 1999 to that in 2004?
Offer a terse response. 0.92. What is the ratio of the Enrollment rate (%) in Middle East & North Africa (developing only) in 1999 to that in 2004?
Offer a terse response. 0.91. What is the ratio of the Enrollment rate (%) of Bahamas in 1999 to that in 2004?
Provide a succinct answer. 0.95. What is the ratio of the Enrollment rate (%) of Lao PDR in 1999 to that in 2004?
Provide a short and direct response. 0.95. What is the ratio of the Enrollment rate (%) in Middle East & North Africa (all income levels) in 1999 to that in 2005?
Give a very brief answer. 0.92. What is the ratio of the Enrollment rate (%) in Middle East & North Africa (developing only) in 1999 to that in 2005?
Provide a short and direct response. 0.91. What is the ratio of the Enrollment rate (%) of Bahamas in 1999 to that in 2005?
Your answer should be very brief. 0.91. What is the ratio of the Enrollment rate (%) in Lao PDR in 1999 to that in 2005?
Provide a succinct answer. 0.93. What is the ratio of the Enrollment rate (%) of Middle East & North Africa (all income levels) in 1999 to that in 2006?
Your answer should be very brief. 0.91. What is the ratio of the Enrollment rate (%) in Middle East & North Africa (developing only) in 1999 to that in 2006?
Offer a very short reply. 0.9. What is the ratio of the Enrollment rate (%) of Bahamas in 1999 to that in 2006?
Give a very brief answer. 0.92. What is the ratio of the Enrollment rate (%) of Lao PDR in 1999 to that in 2006?
Provide a succinct answer. 0.92. What is the ratio of the Enrollment rate (%) in Middle East & North Africa (all income levels) in 1999 to that in 2008?
Make the answer very short. 0.9. What is the ratio of the Enrollment rate (%) of Middle East & North Africa (developing only) in 1999 to that in 2008?
Provide a succinct answer. 0.9. What is the ratio of the Enrollment rate (%) in Bahamas in 1999 to that in 2008?
Make the answer very short. 0.91. What is the ratio of the Enrollment rate (%) in Lao PDR in 1999 to that in 2008?
Provide a succinct answer. 0.85. What is the ratio of the Enrollment rate (%) in Middle East & North Africa (all income levels) in 1999 to that in 2009?
Provide a succinct answer. 0.89. What is the ratio of the Enrollment rate (%) in Middle East & North Africa (developing only) in 1999 to that in 2009?
Provide a succinct answer. 0.89. What is the ratio of the Enrollment rate (%) of Bahamas in 1999 to that in 2009?
Keep it short and to the point. 0.92. What is the ratio of the Enrollment rate (%) of Lao PDR in 1999 to that in 2009?
Your answer should be very brief. 0.82. What is the ratio of the Enrollment rate (%) of Middle East & North Africa (developing only) in 2004 to that in 2005?
Offer a terse response. 1. What is the ratio of the Enrollment rate (%) in Bahamas in 2004 to that in 2005?
Your answer should be compact. 0.95. What is the ratio of the Enrollment rate (%) in Lao PDR in 2004 to that in 2005?
Provide a short and direct response. 0.98. What is the ratio of the Enrollment rate (%) of Middle East & North Africa (all income levels) in 2004 to that in 2006?
Provide a succinct answer. 0.99. What is the ratio of the Enrollment rate (%) of Bahamas in 2004 to that in 2006?
Give a very brief answer. 0.97. What is the ratio of the Enrollment rate (%) in Lao PDR in 2004 to that in 2006?
Offer a very short reply. 0.97. What is the ratio of the Enrollment rate (%) in Middle East & North Africa (all income levels) in 2004 to that in 2008?
Keep it short and to the point. 0.98. What is the ratio of the Enrollment rate (%) in Middle East & North Africa (developing only) in 2004 to that in 2008?
Give a very brief answer. 0.98. What is the ratio of the Enrollment rate (%) of Bahamas in 2004 to that in 2008?
Offer a terse response. 0.96. What is the ratio of the Enrollment rate (%) in Lao PDR in 2004 to that in 2008?
Offer a very short reply. 0.9. What is the ratio of the Enrollment rate (%) in Middle East & North Africa (developing only) in 2004 to that in 2009?
Ensure brevity in your answer.  0.98. What is the ratio of the Enrollment rate (%) of Bahamas in 2004 to that in 2009?
Your response must be concise. 0.96. What is the ratio of the Enrollment rate (%) of Lao PDR in 2004 to that in 2009?
Keep it short and to the point. 0.86. What is the ratio of the Enrollment rate (%) in Middle East & North Africa (all income levels) in 2005 to that in 2006?
Your response must be concise. 0.99. What is the ratio of the Enrollment rate (%) of Middle East & North Africa (developing only) in 2005 to that in 2006?
Offer a very short reply. 0.99. What is the ratio of the Enrollment rate (%) of Bahamas in 2005 to that in 2006?
Ensure brevity in your answer.  1.01. What is the ratio of the Enrollment rate (%) in Lao PDR in 2005 to that in 2006?
Offer a very short reply. 0.98. What is the ratio of the Enrollment rate (%) of Middle East & North Africa (all income levels) in 2005 to that in 2008?
Ensure brevity in your answer.  0.98. What is the ratio of the Enrollment rate (%) of Middle East & North Africa (developing only) in 2005 to that in 2008?
Your response must be concise. 0.98. What is the ratio of the Enrollment rate (%) of Bahamas in 2005 to that in 2008?
Your answer should be very brief. 1. What is the ratio of the Enrollment rate (%) of Lao PDR in 2005 to that in 2008?
Give a very brief answer. 0.92. What is the ratio of the Enrollment rate (%) in Middle East & North Africa (all income levels) in 2005 to that in 2009?
Provide a succinct answer. 0.97. What is the ratio of the Enrollment rate (%) in Middle East & North Africa (developing only) in 2005 to that in 2009?
Give a very brief answer. 0.97. What is the ratio of the Enrollment rate (%) of Bahamas in 2005 to that in 2009?
Keep it short and to the point. 1.01. What is the ratio of the Enrollment rate (%) of Lao PDR in 2005 to that in 2009?
Your answer should be compact. 0.88. What is the ratio of the Enrollment rate (%) of Middle East & North Africa (all income levels) in 2006 to that in 2008?
Your answer should be compact. 0.99. What is the ratio of the Enrollment rate (%) of Bahamas in 2006 to that in 2008?
Ensure brevity in your answer.  0.99. What is the ratio of the Enrollment rate (%) of Lao PDR in 2006 to that in 2008?
Make the answer very short. 0.93. What is the ratio of the Enrollment rate (%) in Middle East & North Africa (developing only) in 2006 to that in 2009?
Offer a terse response. 0.99. What is the ratio of the Enrollment rate (%) of Lao PDR in 2006 to that in 2009?
Your answer should be compact. 0.89. What is the ratio of the Enrollment rate (%) in Middle East & North Africa (all income levels) in 2008 to that in 2009?
Your response must be concise. 0.99. What is the ratio of the Enrollment rate (%) in Middle East & North Africa (developing only) in 2008 to that in 2009?
Your answer should be compact. 0.99. What is the ratio of the Enrollment rate (%) in Bahamas in 2008 to that in 2009?
Offer a terse response. 1.01. What is the ratio of the Enrollment rate (%) in Lao PDR in 2008 to that in 2009?
Your response must be concise. 0.96. What is the difference between the highest and the second highest Enrollment rate (%) in Middle East & North Africa (all income levels)?
Give a very brief answer. 0.83. What is the difference between the highest and the second highest Enrollment rate (%) in Middle East & North Africa (developing only)?
Make the answer very short. 0.5. What is the difference between the highest and the second highest Enrollment rate (%) of Bahamas?
Make the answer very short. 0.17. What is the difference between the highest and the second highest Enrollment rate (%) of Lao PDR?
Provide a succinct answer. 3.78. What is the difference between the highest and the lowest Enrollment rate (%) in Middle East & North Africa (all income levels)?
Make the answer very short. 10.26. What is the difference between the highest and the lowest Enrollment rate (%) in Middle East & North Africa (developing only)?
Keep it short and to the point. 10.02. What is the difference between the highest and the lowest Enrollment rate (%) in Bahamas?
Ensure brevity in your answer.  9.17. What is the difference between the highest and the lowest Enrollment rate (%) in Lao PDR?
Offer a terse response. 16.05. 